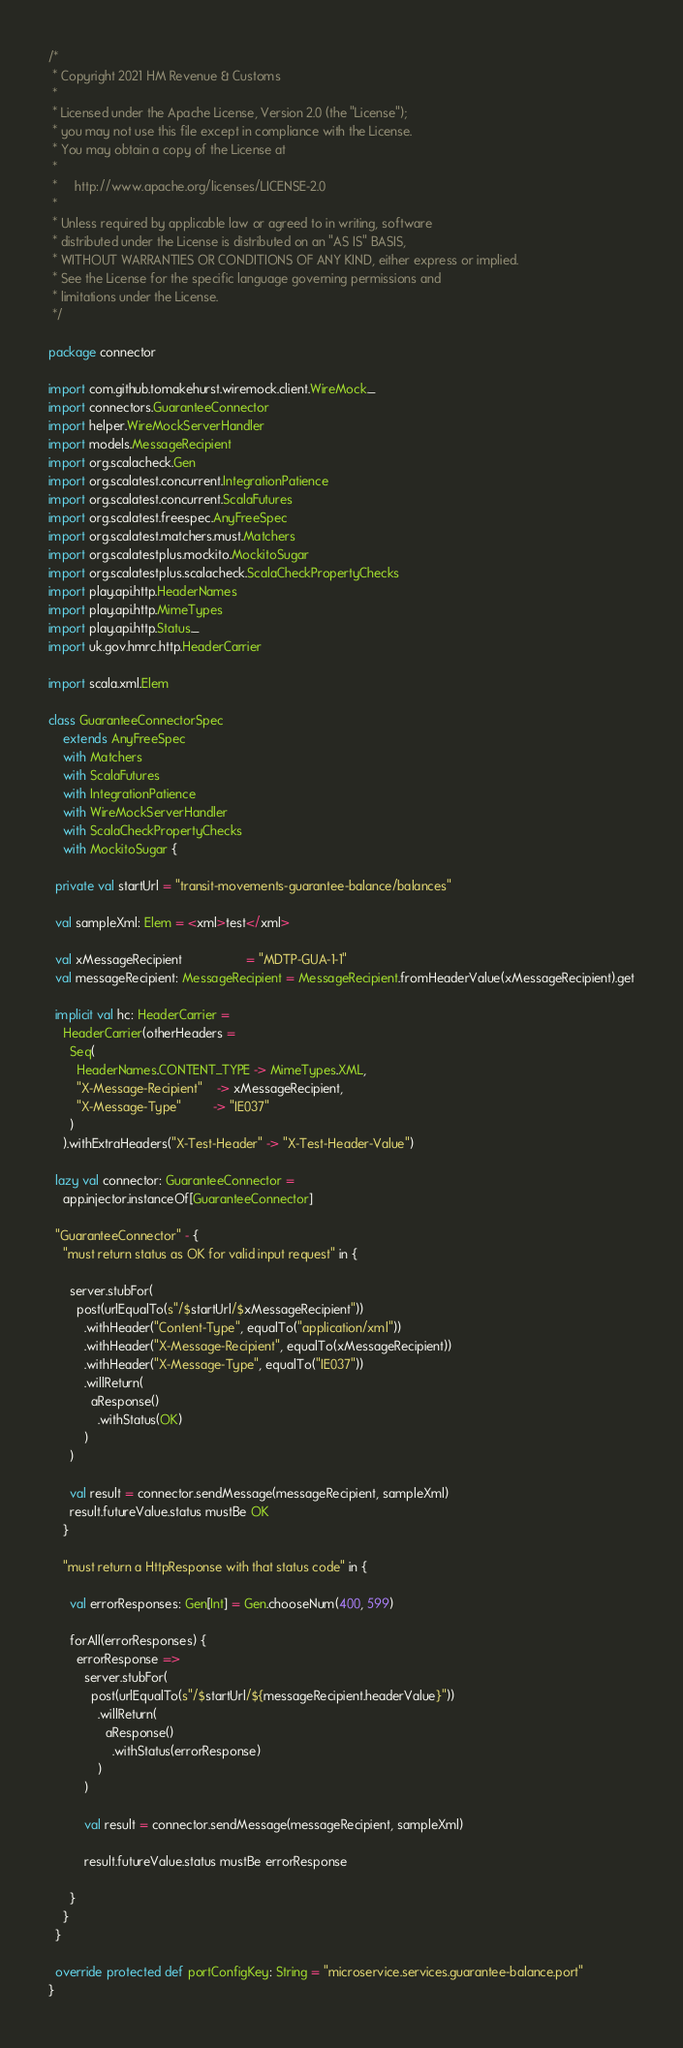<code> <loc_0><loc_0><loc_500><loc_500><_Scala_>/*
 * Copyright 2021 HM Revenue & Customs
 *
 * Licensed under the Apache License, Version 2.0 (the "License");
 * you may not use this file except in compliance with the License.
 * You may obtain a copy of the License at
 *
 *     http://www.apache.org/licenses/LICENSE-2.0
 *
 * Unless required by applicable law or agreed to in writing, software
 * distributed under the License is distributed on an "AS IS" BASIS,
 * WITHOUT WARRANTIES OR CONDITIONS OF ANY KIND, either express or implied.
 * See the License for the specific language governing permissions and
 * limitations under the License.
 */

package connector

import com.github.tomakehurst.wiremock.client.WireMock._
import connectors.GuaranteeConnector
import helper.WireMockServerHandler
import models.MessageRecipient
import org.scalacheck.Gen
import org.scalatest.concurrent.IntegrationPatience
import org.scalatest.concurrent.ScalaFutures
import org.scalatest.freespec.AnyFreeSpec
import org.scalatest.matchers.must.Matchers
import org.scalatestplus.mockito.MockitoSugar
import org.scalatestplus.scalacheck.ScalaCheckPropertyChecks
import play.api.http.HeaderNames
import play.api.http.MimeTypes
import play.api.http.Status._
import uk.gov.hmrc.http.HeaderCarrier

import scala.xml.Elem

class GuaranteeConnectorSpec
    extends AnyFreeSpec
    with Matchers
    with ScalaFutures
    with IntegrationPatience
    with WireMockServerHandler
    with ScalaCheckPropertyChecks
    with MockitoSugar {

  private val startUrl = "transit-movements-guarantee-balance/balances"

  val sampleXml: Elem = <xml>test</xml>

  val xMessageRecipient                  = "MDTP-GUA-1-1"
  val messageRecipient: MessageRecipient = MessageRecipient.fromHeaderValue(xMessageRecipient).get

  implicit val hc: HeaderCarrier =
    HeaderCarrier(otherHeaders =
      Seq(
        HeaderNames.CONTENT_TYPE -> MimeTypes.XML,
        "X-Message-Recipient"    -> xMessageRecipient,
        "X-Message-Type"         -> "IE037"
      )
    ).withExtraHeaders("X-Test-Header" -> "X-Test-Header-Value")

  lazy val connector: GuaranteeConnector =
    app.injector.instanceOf[GuaranteeConnector]

  "GuaranteeConnector" - {
    "must return status as OK for valid input request" in {

      server.stubFor(
        post(urlEqualTo(s"/$startUrl/$xMessageRecipient"))
          .withHeader("Content-Type", equalTo("application/xml"))
          .withHeader("X-Message-Recipient", equalTo(xMessageRecipient))
          .withHeader("X-Message-Type", equalTo("IE037"))
          .willReturn(
            aResponse()
              .withStatus(OK)
          )
      )

      val result = connector.sendMessage(messageRecipient, sampleXml)
      result.futureValue.status mustBe OK
    }

    "must return a HttpResponse with that status code" in {

      val errorResponses: Gen[Int] = Gen.chooseNum(400, 599)

      forAll(errorResponses) {
        errorResponse =>
          server.stubFor(
            post(urlEqualTo(s"/$startUrl/${messageRecipient.headerValue}"))
              .willReturn(
                aResponse()
                  .withStatus(errorResponse)
              )
          )

          val result = connector.sendMessage(messageRecipient, sampleXml)

          result.futureValue.status mustBe errorResponse

      }
    }
  }

  override protected def portConfigKey: String = "microservice.services.guarantee-balance.port"
}
</code> 